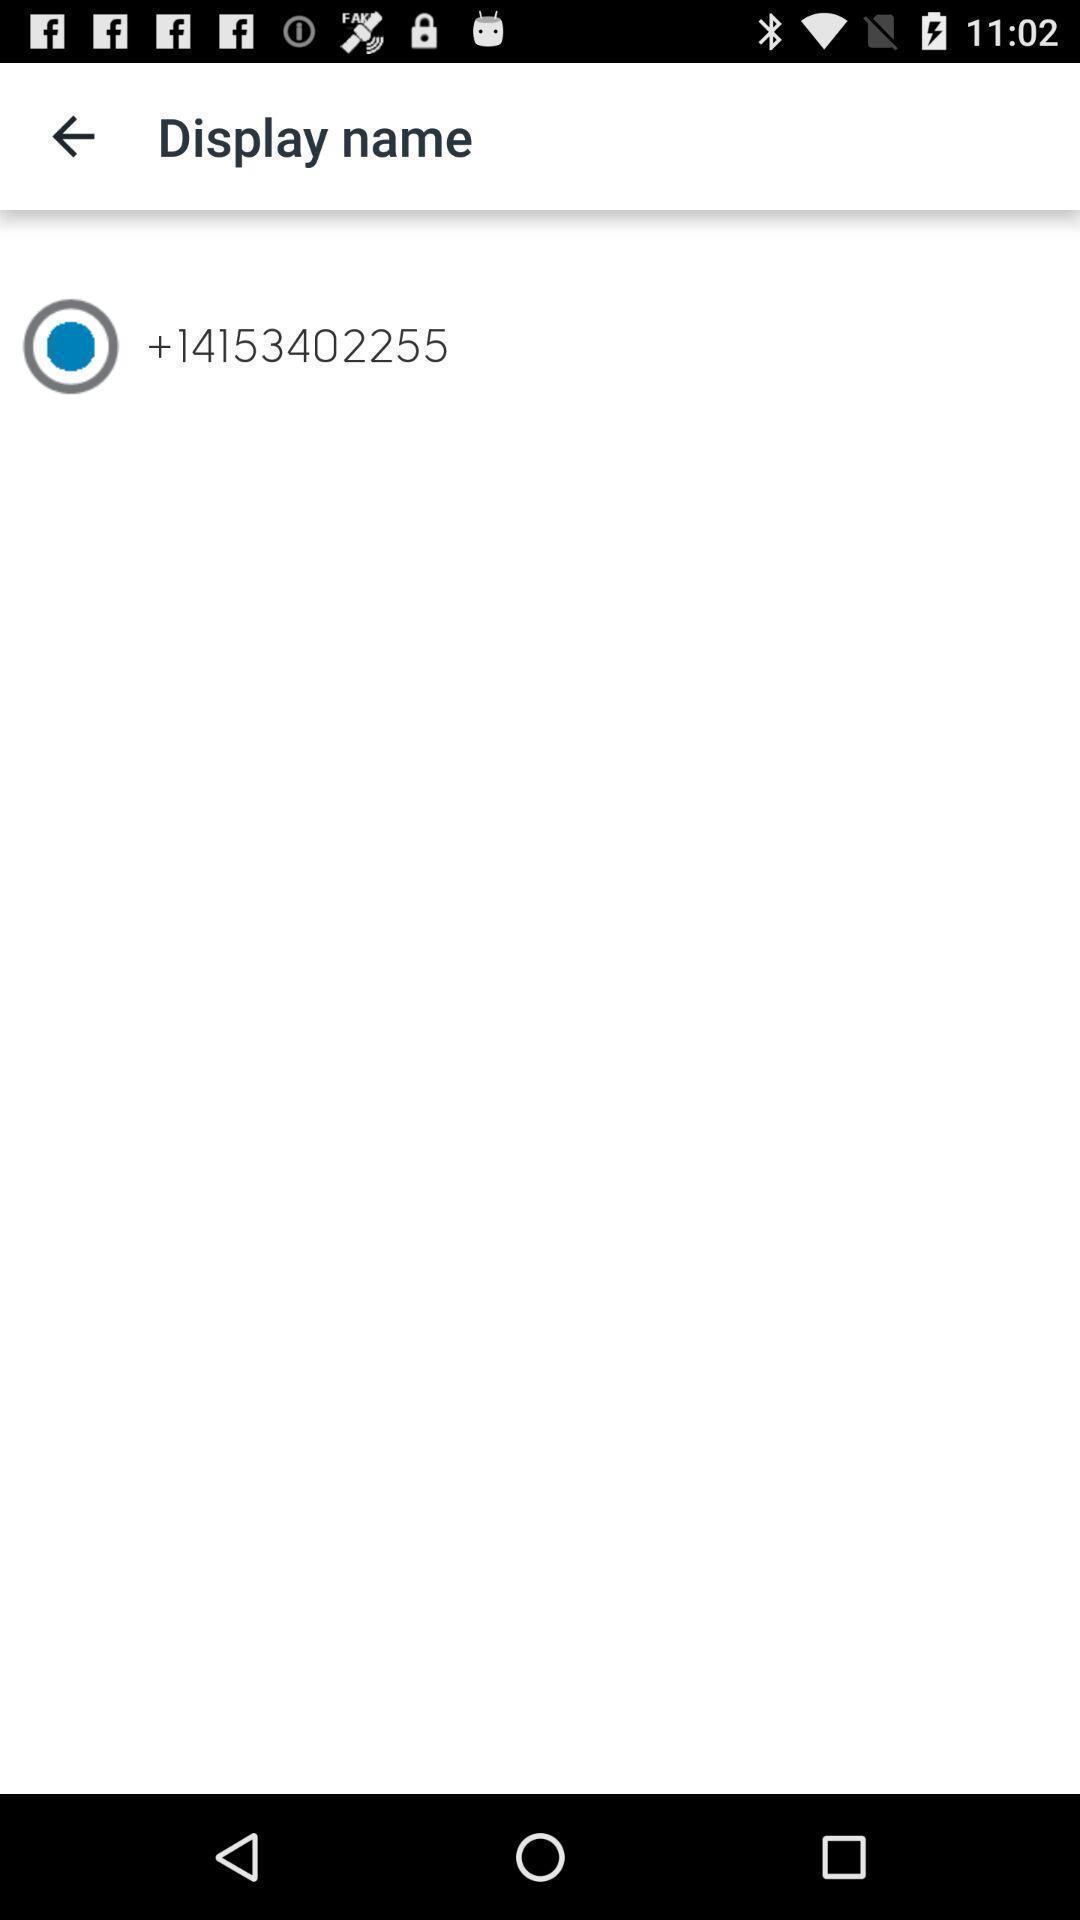Describe the visual elements of this screenshot. Page for displaying a name for a contact. 